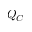Convert formula to latex. <formula><loc_0><loc_0><loc_500><loc_500>Q _ { C }</formula> 